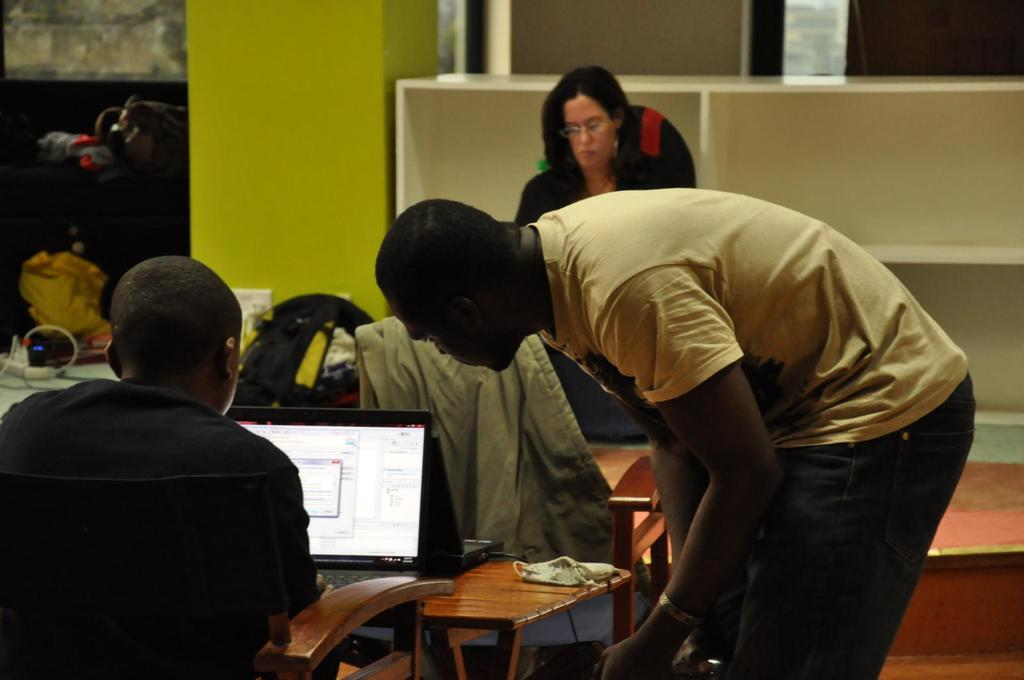What is the position of the person in the image? There is a person sitting in the image. Is there another person in the image? Yes, there is a person standing beside the sitting person. What is present in the image for placing objects? There is a table in the image. Can you describe the background of the image? There is a woman, a wall, a rack, and bags in the background of the image. What type of nest can be seen in the image? There is no nest present in the image. How does the moon affect the sitting person in the image? The moon is not visible in the image, so it cannot affect the sitting person. 